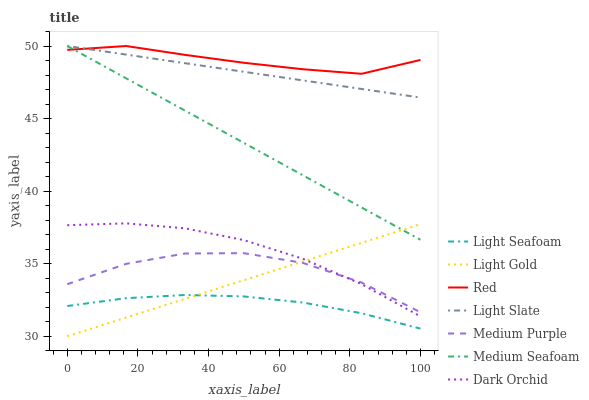Does Dark Orchid have the minimum area under the curve?
Answer yes or no. No. Does Dark Orchid have the maximum area under the curve?
Answer yes or no. No. Is Dark Orchid the smoothest?
Answer yes or no. No. Is Dark Orchid the roughest?
Answer yes or no. No. Does Dark Orchid have the lowest value?
Answer yes or no. No. Does Dark Orchid have the highest value?
Answer yes or no. No. Is Dark Orchid less than Red?
Answer yes or no. Yes. Is Medium Purple greater than Light Seafoam?
Answer yes or no. Yes. Does Dark Orchid intersect Red?
Answer yes or no. No. 